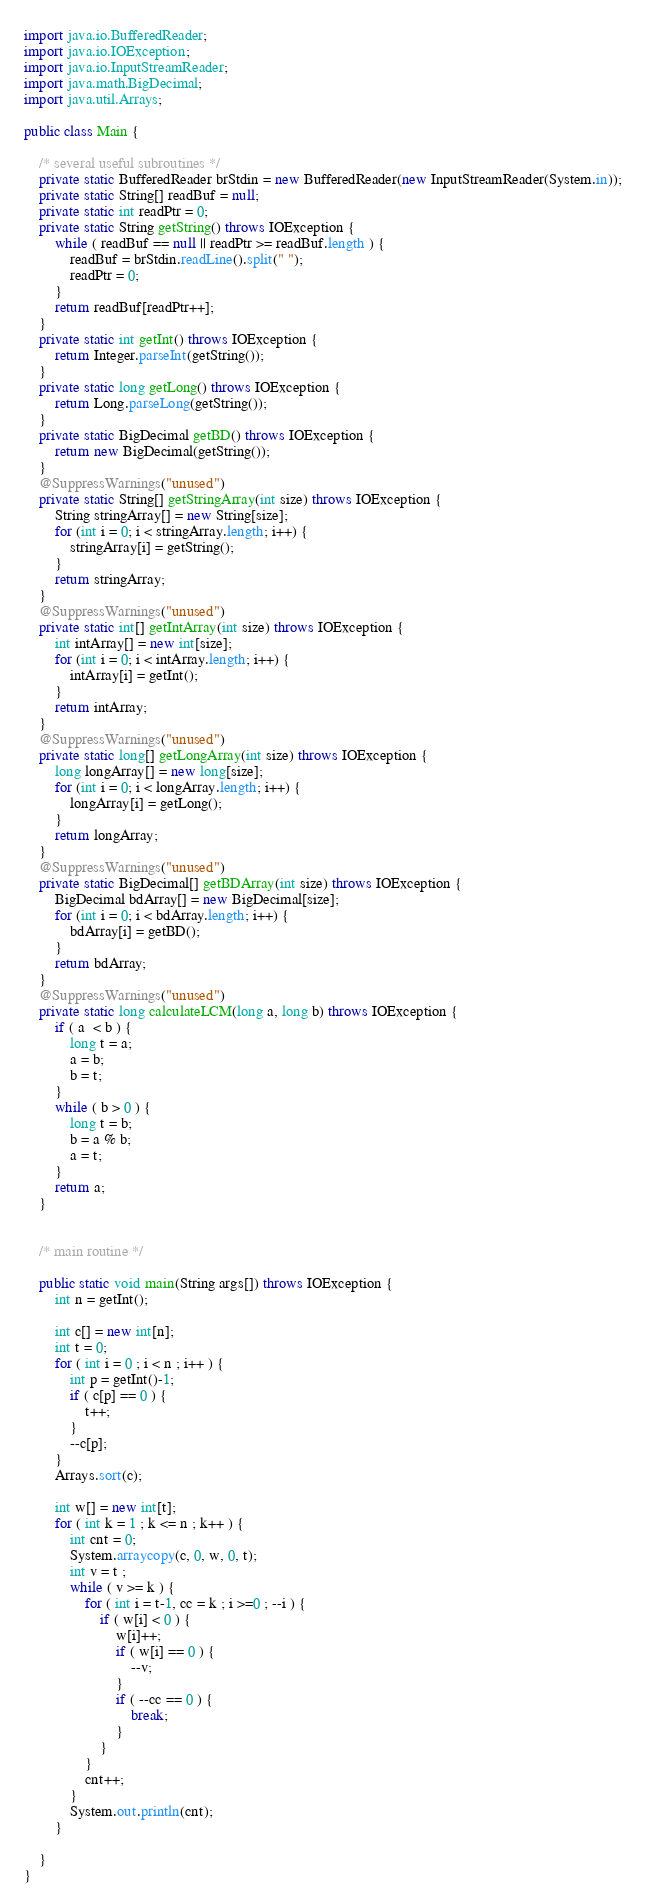Convert code to text. <code><loc_0><loc_0><loc_500><loc_500><_Java_>import java.io.BufferedReader;
import java.io.IOException;
import java.io.InputStreamReader;
import java.math.BigDecimal;
import java.util.Arrays;

public class Main {

	/* several useful subroutines */
	private static BufferedReader brStdin = new BufferedReader(new InputStreamReader(System.in));
	private static String[] readBuf = null;
	private static int readPtr = 0;
	private static String getString() throws IOException {
		while ( readBuf == null || readPtr >= readBuf.length ) {
			readBuf = brStdin.readLine().split(" ");
			readPtr = 0;
		}
		return readBuf[readPtr++];
	}
	private static int getInt() throws IOException {
		return Integer.parseInt(getString());
	}
	private static long getLong() throws IOException {
		return Long.parseLong(getString());
	}
	private static BigDecimal getBD() throws IOException {
		return new BigDecimal(getString());
	}
	@SuppressWarnings("unused")
	private static String[] getStringArray(int size) throws IOException {
		String stringArray[] = new String[size];
		for (int i = 0; i < stringArray.length; i++) {
			stringArray[i] = getString();
		}
		return stringArray;
	}
	@SuppressWarnings("unused")
	private static int[] getIntArray(int size) throws IOException {
		int intArray[] = new int[size];
		for (int i = 0; i < intArray.length; i++) {
			intArray[i] = getInt();
		}
		return intArray;
	}
	@SuppressWarnings("unused")
	private static long[] getLongArray(int size) throws IOException {
		long longArray[] = new long[size];
		for (int i = 0; i < longArray.length; i++) {
			longArray[i] = getLong();
		}
		return longArray;
	}
	@SuppressWarnings("unused")
	private static BigDecimal[] getBDArray(int size) throws IOException {
		BigDecimal bdArray[] = new BigDecimal[size];
		for (int i = 0; i < bdArray.length; i++) {
			bdArray[i] = getBD();
		}
		return bdArray;
	}
	@SuppressWarnings("unused")
	private static long calculateLCM(long a, long b) throws IOException {
		if ( a  < b ) {
			long t = a;
			a = b;
			b = t;
		}
		while ( b > 0 ) {
			long t = b;
			b = a % b;
			a = t;
		}
		return a;
	}

	
	/* main routine */
	
	public static void main(String args[]) throws IOException {
		int n = getInt();

		int c[] = new int[n];
		int t = 0;
		for ( int i = 0 ; i < n ; i++ ) {
			int p = getInt()-1;
			if ( c[p] == 0 ) {
				t++;
			}
			--c[p];
		}
		Arrays.sort(c);

		int w[] = new int[t];
		for ( int k = 1 ; k <= n ; k++ ) {
			int cnt = 0;
			System.arraycopy(c, 0, w, 0, t);
			int v = t ;
			while ( v >= k ) {
				for ( int i = t-1, cc = k ; i >=0 ; --i ) {
					if ( w[i] < 0 ) {
						w[i]++;
						if ( w[i] == 0 ) {
							--v;
						}
						if ( --cc == 0 ) {
							break;
						}
					}
				}
				cnt++;
			}
			System.out.println(cnt);
		}
		
	}
}
</code> 